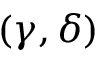<formula> <loc_0><loc_0><loc_500><loc_500>( \gamma , \delta )</formula> 